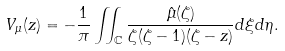Convert formula to latex. <formula><loc_0><loc_0><loc_500><loc_500>V _ { \mu } ( z ) = - \frac { 1 } { \pi } \iint _ { \mathbb { C } } \frac { \hat { \mu } ( \zeta ) } { \zeta ( \zeta - 1 ) ( \zeta - z ) } d \xi d \eta .</formula> 